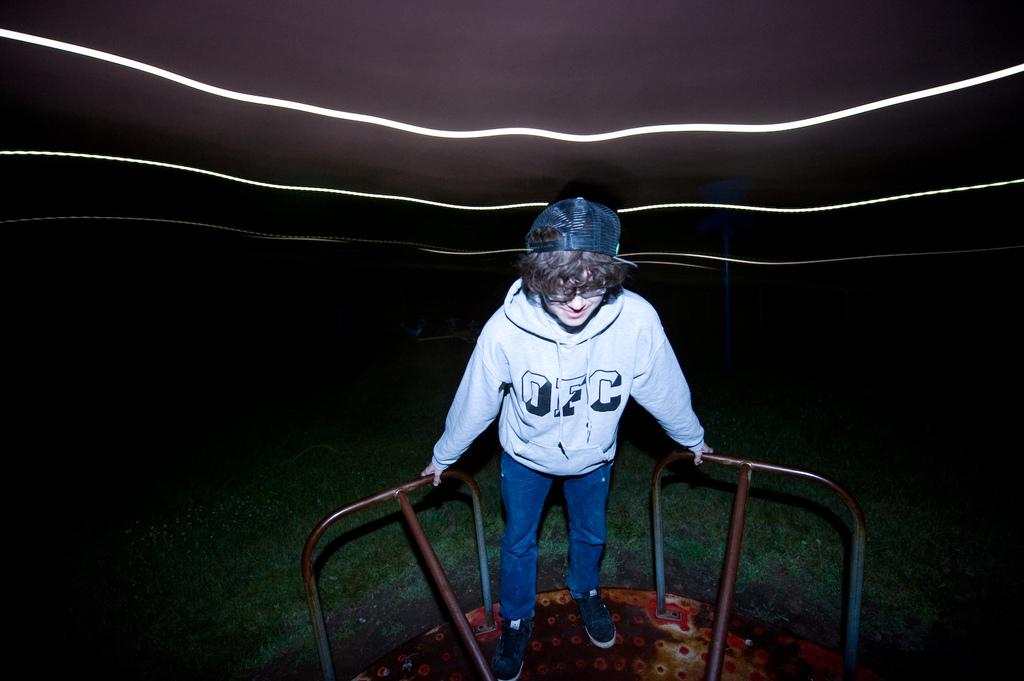What is the main subject of the image? The main subject of the image is a person standing in the middle of the image. What is the person standing on? The person is standing on an iron object. What is the person wearing on their upper body? The person is wearing a white sweater. What type of headwear is the person wearing? The person is wearing a black cap. What type of banana is the person holding in the image? There is no banana present in the image; the person is not holding any fruit or object. What type of vessel is the person using to sail in the image? There is no vessel present in the image; the person is standing on an iron object, not sailing. 